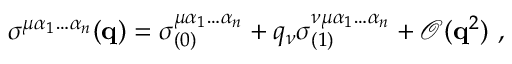Convert formula to latex. <formula><loc_0><loc_0><loc_500><loc_500>\sigma ^ { \mu \alpha _ { 1 } \hdots \alpha _ { n } } ( q ) = \sigma _ { ( 0 ) } ^ { \mu \alpha _ { 1 } \hdots \alpha _ { n } } + q _ { \nu } \sigma _ { ( 1 ) } ^ { \nu \mu \alpha _ { 1 } \hdots \alpha _ { n } } + \mathcal { O } ( q ^ { 2 } ) ,</formula> 